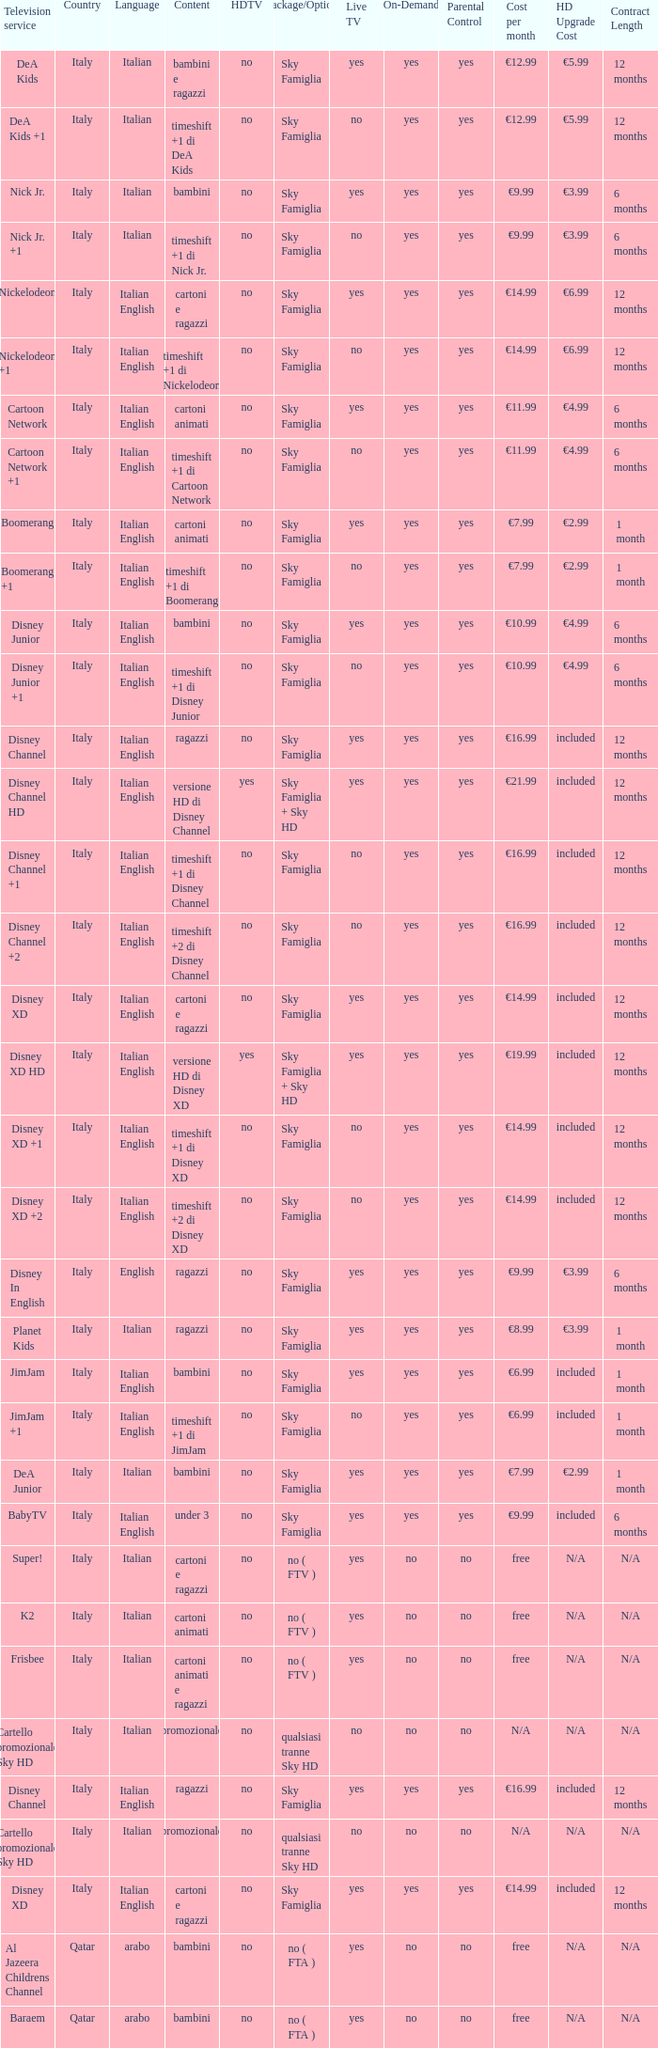What is the HDTV when the content shows a timeshift +1 di disney junior? No. 